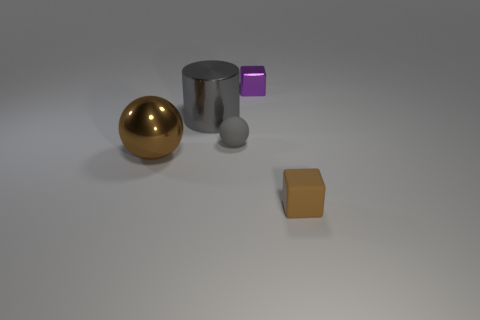Is there anything else that has the same color as the large metal ball? In the image provided, the large spherical object has a distinctive gold color, and upon careful observation, no other objects share the exact same hue. The other objects present include a silver cylinder, a purple-blue cube, a grey sphere, and an orange square, each sporting its own unique color. 